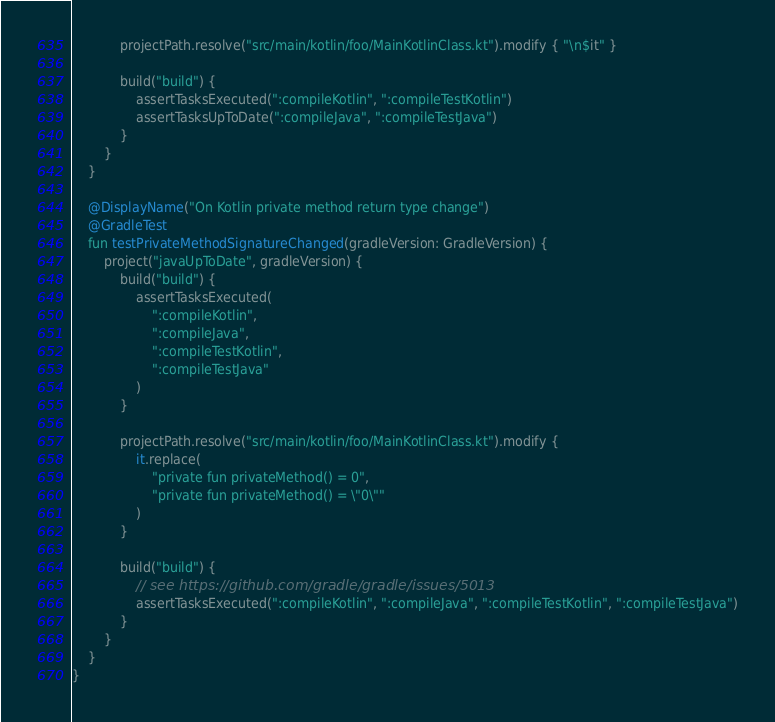<code> <loc_0><loc_0><loc_500><loc_500><_Kotlin_>            projectPath.resolve("src/main/kotlin/foo/MainKotlinClass.kt").modify { "\n$it" }

            build("build") {
                assertTasksExecuted(":compileKotlin", ":compileTestKotlin")
                assertTasksUpToDate(":compileJava", ":compileTestJava")
            }
        }
    }

    @DisplayName("On Kotlin private method return type change")
    @GradleTest
    fun testPrivateMethodSignatureChanged(gradleVersion: GradleVersion) {
        project("javaUpToDate", gradleVersion) {
            build("build") {
                assertTasksExecuted(
                    ":compileKotlin",
                    ":compileJava",
                    ":compileTestKotlin",
                    ":compileTestJava"
                )
            }

            projectPath.resolve("src/main/kotlin/foo/MainKotlinClass.kt").modify {
                it.replace(
                    "private fun privateMethod() = 0",
                    "private fun privateMethod() = \"0\""
                )
            }

            build("build") {
                // see https://github.com/gradle/gradle/issues/5013
                assertTasksExecuted(":compileKotlin", ":compileJava", ":compileTestKotlin", ":compileTestJava")
            }
        }
    }
}</code> 